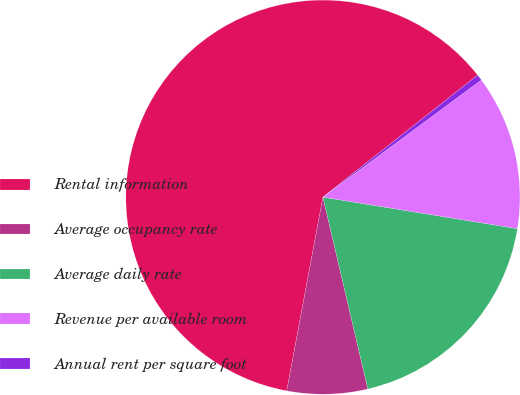Convert chart. <chart><loc_0><loc_0><loc_500><loc_500><pie_chart><fcel>Rental information<fcel>Average occupancy rate<fcel>Average daily rate<fcel>Revenue per available room<fcel>Annual rent per square foot<nl><fcel>61.43%<fcel>6.6%<fcel>18.78%<fcel>12.69%<fcel>0.5%<nl></chart> 